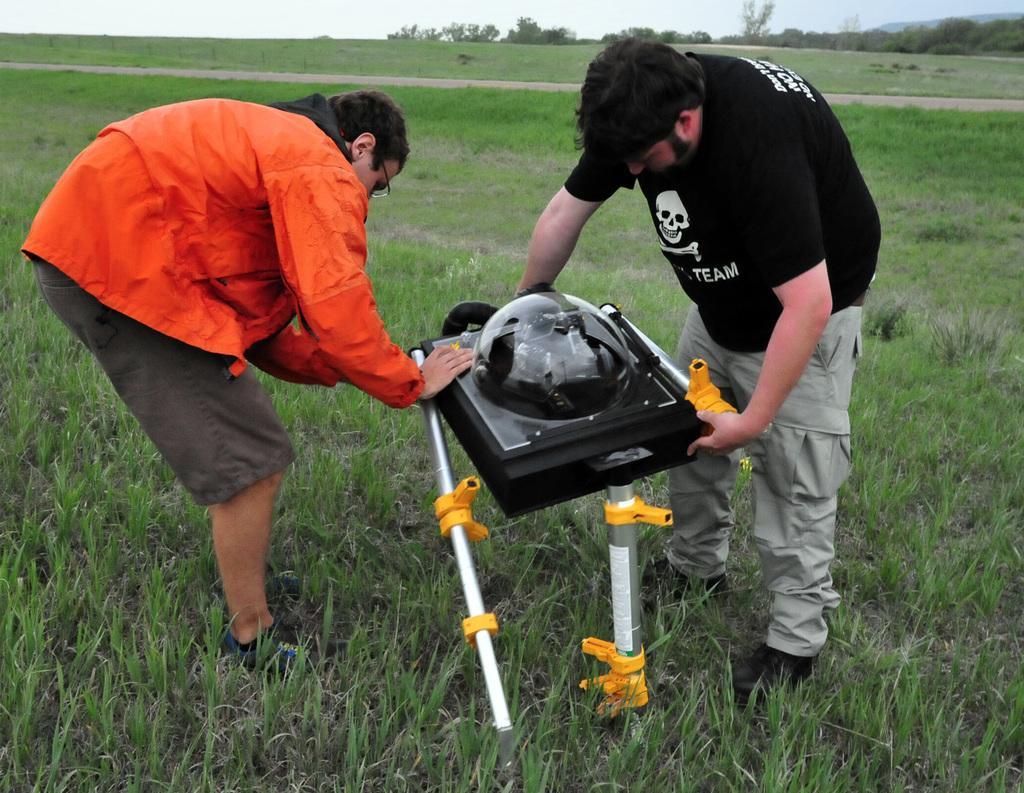Describe this image in one or two sentences. There are two people standing and holding an object and we can see grass. In the background we can see trees and sky. 